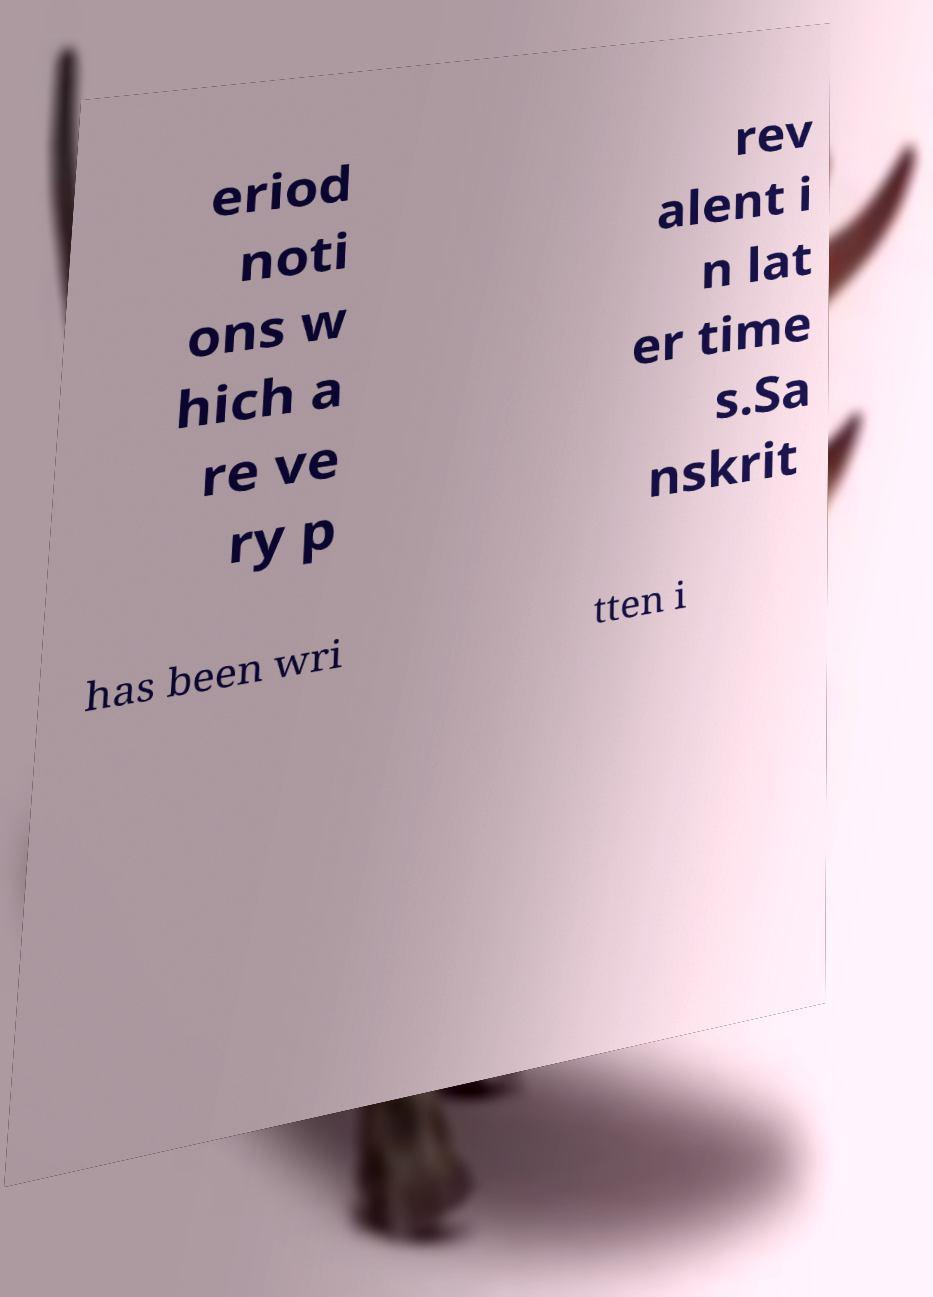Can you read and provide the text displayed in the image?This photo seems to have some interesting text. Can you extract and type it out for me? eriod noti ons w hich a re ve ry p rev alent i n lat er time s.Sa nskrit has been wri tten i 